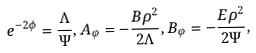<formula> <loc_0><loc_0><loc_500><loc_500>e ^ { - 2 \phi } = \frac { \Lambda } { \Psi } , A _ { \varphi } = - \frac { B \rho ^ { 2 } } { 2 \Lambda } , B _ { \varphi } = - \frac { E \rho ^ { 2 } } { 2 \Psi } ,</formula> 